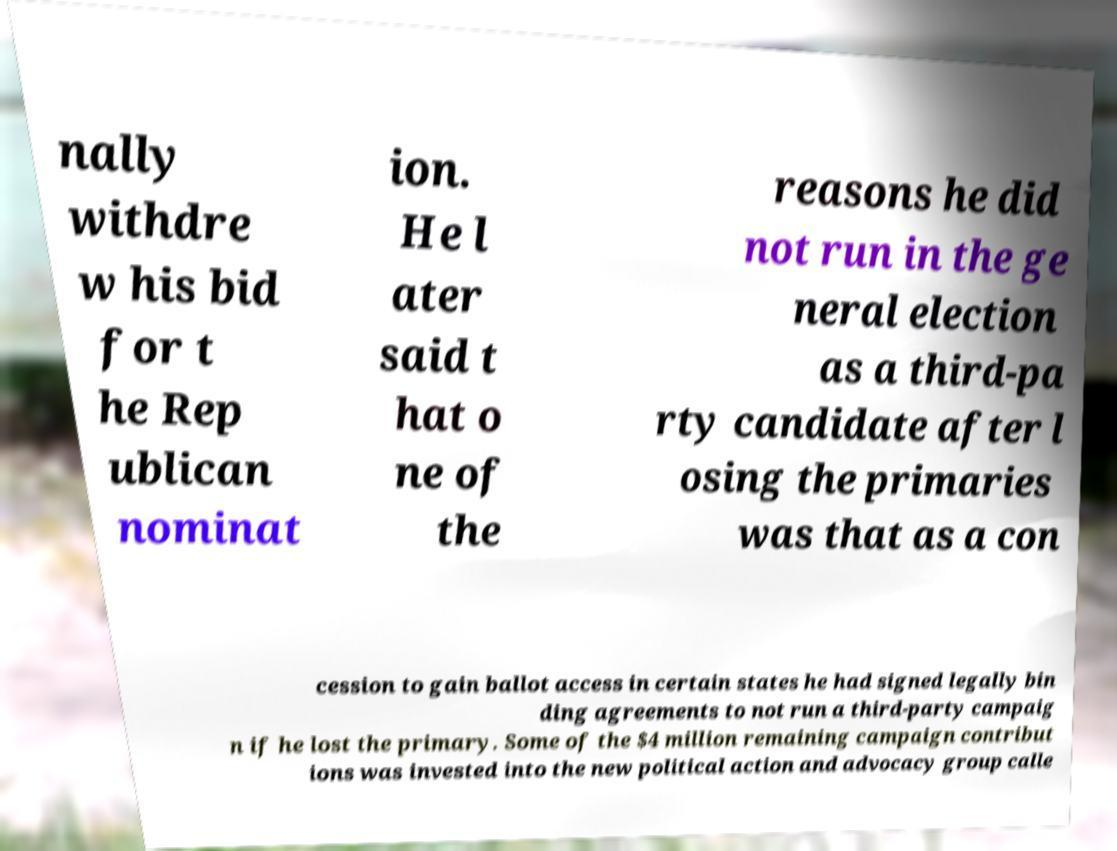Could you assist in decoding the text presented in this image and type it out clearly? nally withdre w his bid for t he Rep ublican nominat ion. He l ater said t hat o ne of the reasons he did not run in the ge neral election as a third-pa rty candidate after l osing the primaries was that as a con cession to gain ballot access in certain states he had signed legally bin ding agreements to not run a third-party campaig n if he lost the primary. Some of the $4 million remaining campaign contribut ions was invested into the new political action and advocacy group calle 